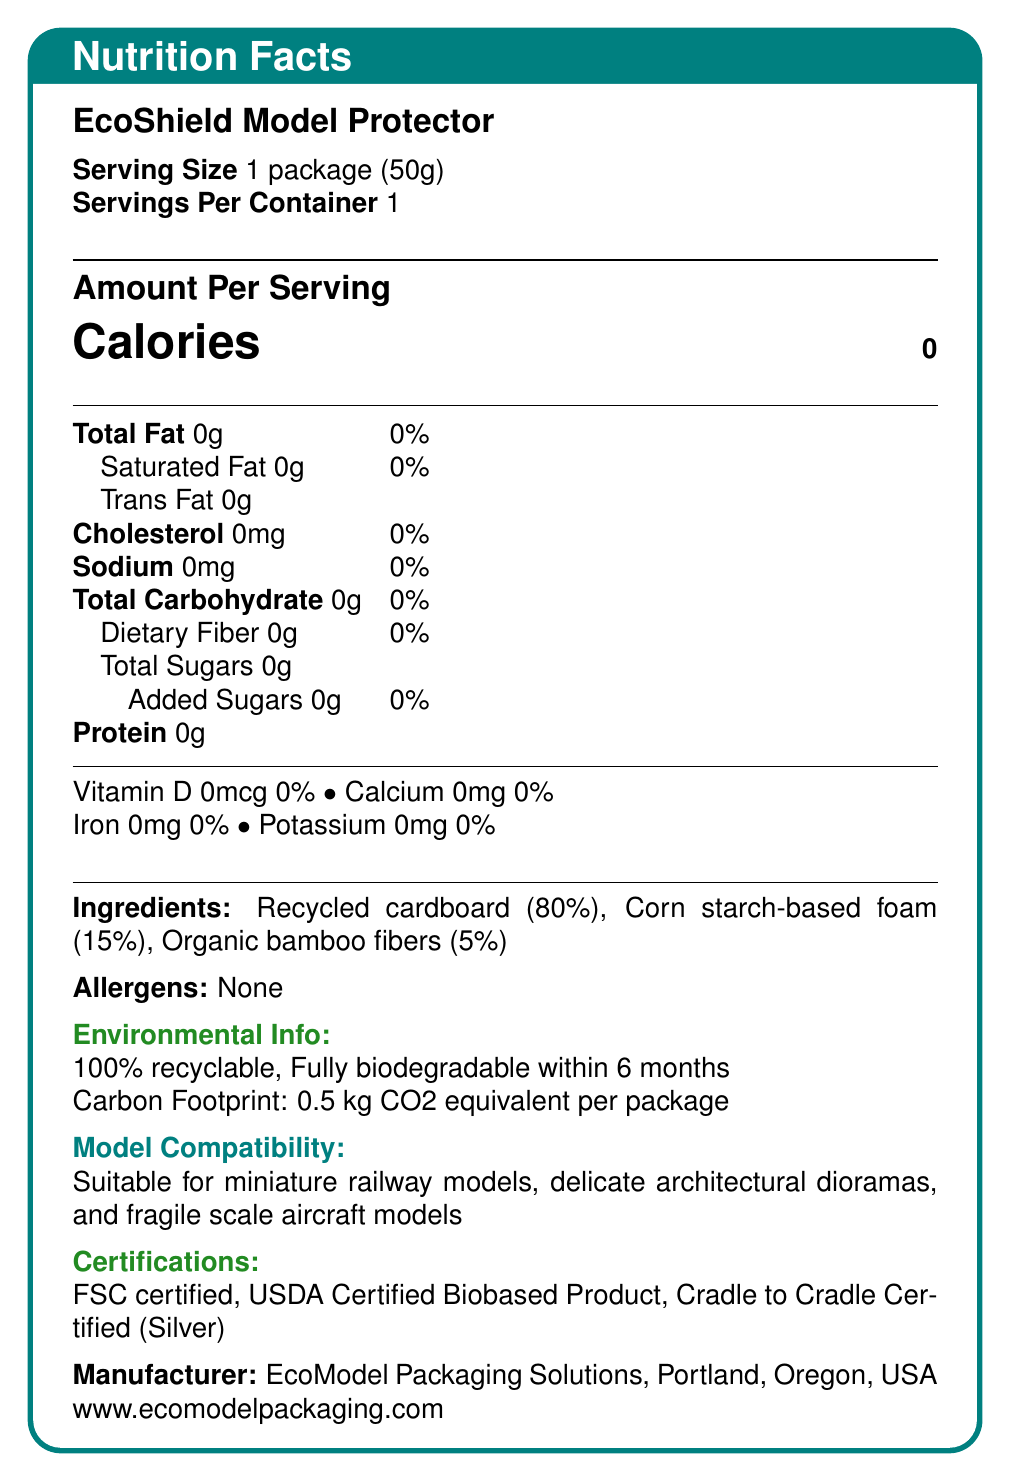what is the serving size of the EcoShield Model Protector? The serving size is explicitly mentioned at the beginning of the document as "1 package (50g)".
Answer: 1 package (50g) how many servings are there per container? The document states "Servings Per Container: 1" right below the serving size.
Answer: 1 how many calories are there per serving? The "Calories" value is clearly listed as 0 in the "Amount Per Serving" section.
Answer: 0 what ingredients are used in the EcoShield Model Protector? These ingredients are listed under the section titled "Ingredients".
Answer: Recycled cardboard (80%), Corn starch-based foam (15%), Organic bamboo fibers (5%) is the EcoShield Model Protector recyclable? The "Environmental Info" section states it is "100% recyclable".
Answer: Yes which certifications does the EcoShield Model Protector have? A. FSC B. USDA Certified Biobased Product C. ISO D. Cradle to Cradle Certified (Silver) The document lists "FSC certified, USDA Certified Biobased Product, Cradle to Cradle Certified (Silver)" under the "Certifications" section.
Answer: C what type of models is this packaging suitable for? A. Scale aircraft models B. Delicate architectural dioramas C. Miniature railway models D. All of the above The "Model Compatibility" section indicates that the packaging is suitable for miniature railway models, delicate architectural dioramas, and fragile scale aircraft models, making D the correct option.
Answer: D is the packaging material biodegradable? The "Environmental Info" section mentions that the packaging is "Fully biodegradable within 6 months".
Answer: Yes what is the maximum weight the EcoShield Model Protector can protect? The "Shipping Info" section states this information directly.
Answer: Protects models up to 500g can I drop my model from 2 meters and expect it to be safe? The "Shipping Info" section states that the packaging can withstand drops up to 1.5 meters.
Answer: No does this product contain any allergens? The "Allergens" section clearly states "None".
Answer: No summarize the main features of the EcoShield Model Protector. This summary captures the product description, environmental friendliness, certifications, and its suitability for protecting various types of models.
Answer: The EcoShield Model Protector, made from recycled cardboard, corn starch-based foam, and organic bamboo fibers, is a 100% recyclable and fully biodegradable packaging material designed to protect delicate models up to 500g in weight. It is certified by FSC, USDA, and Cradle to Cradle, and is suitable for models such as miniature railway models, architectural dioramas, and fragile aircraft models. what is the source of the manufacturer's location? The location of the manufacturer, EcoModel Packaging Solutions, is explicitly mentioned at the end of the document.
Answer: Portland, Oregon, USA how long is the EcoShield Model Protector moisture-resistant for? This information is found in the "Shipping Info" section.
Answer: Water-resistant for up to 30 minutes where should the EcoShield Model Protector be stored? Storage instructions are provided at the end of the document under "Storage Instructions".
Answer: In a cool, dry place away from direct sunlight what is the dietary fiber content of the EcoShield Model Protector? The "Amount Per Serving" section of the document lists dietary fiber as 0g.
Answer: 0g how many grams of protein are in the EcoShield Model Protector? The protein content is listed as 0g in the "Amount Per Serving" section.
Answer: 0g who is the manufacturer of the EcoShield Model Protector? This information is provided under "Manufacturer" at the end of the document.
Answer: EcoModel Packaging Solutions how much vitamin D does the product contain? The amount of vitamin D is listed as 0mcg in the vitamins and minerals section.
Answer: 0mcg does the product contain added sugars? The document clearly states that the product has "Added Sugars: 0g".
Answer: No what is the recycling process for this material? The document states that the product is 100% recyclable but does not provide specific information about the recycling process.
Answer: Cannot be determined 